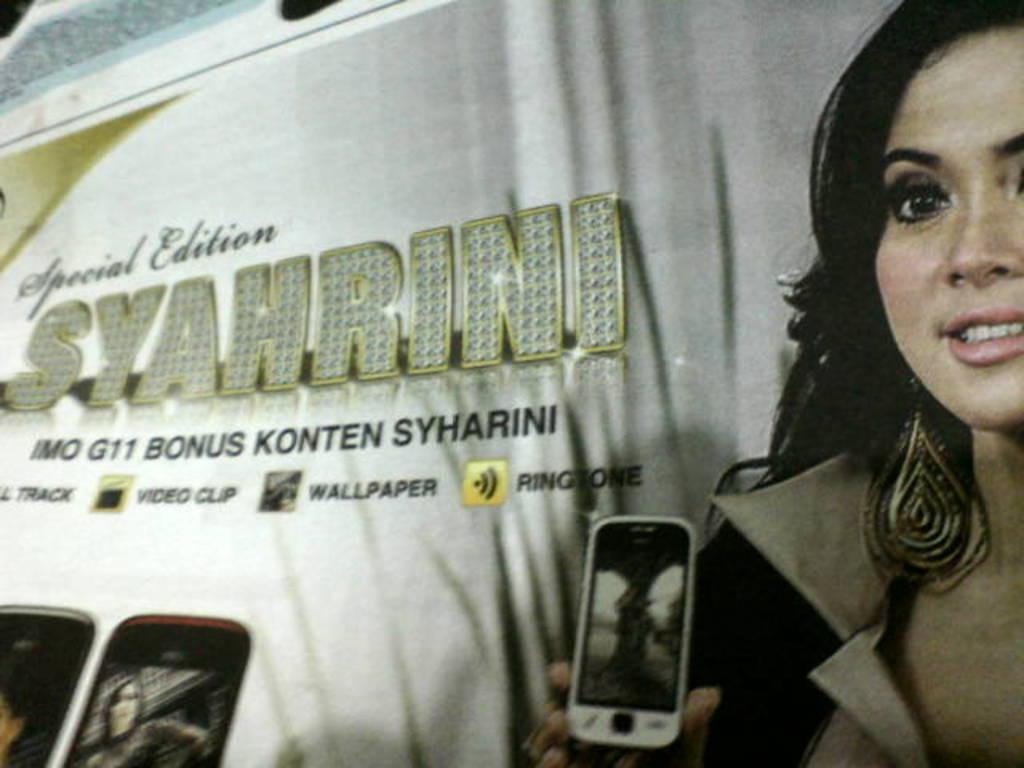Can you describe this image briefly? In this image there is a banner. On the banner we can see a picture of a lady holding a mobile. On the left we can see a text. At the bottom there are mobiles. 